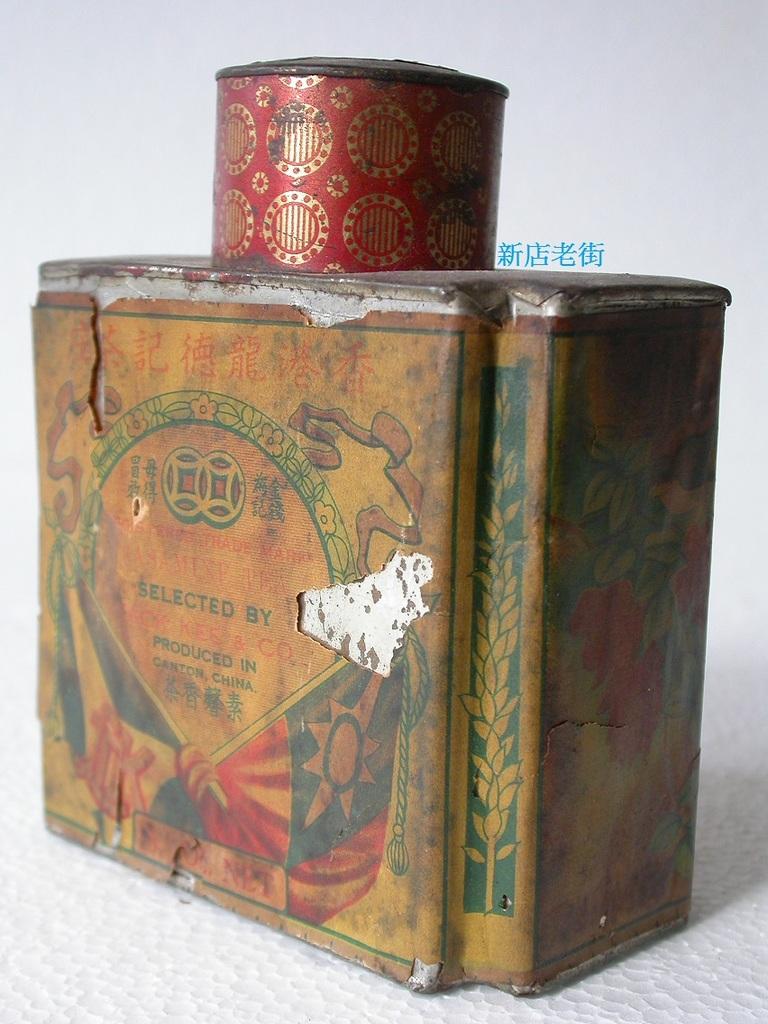What does this box contain?
Ensure brevity in your answer.  Unanswerable. 